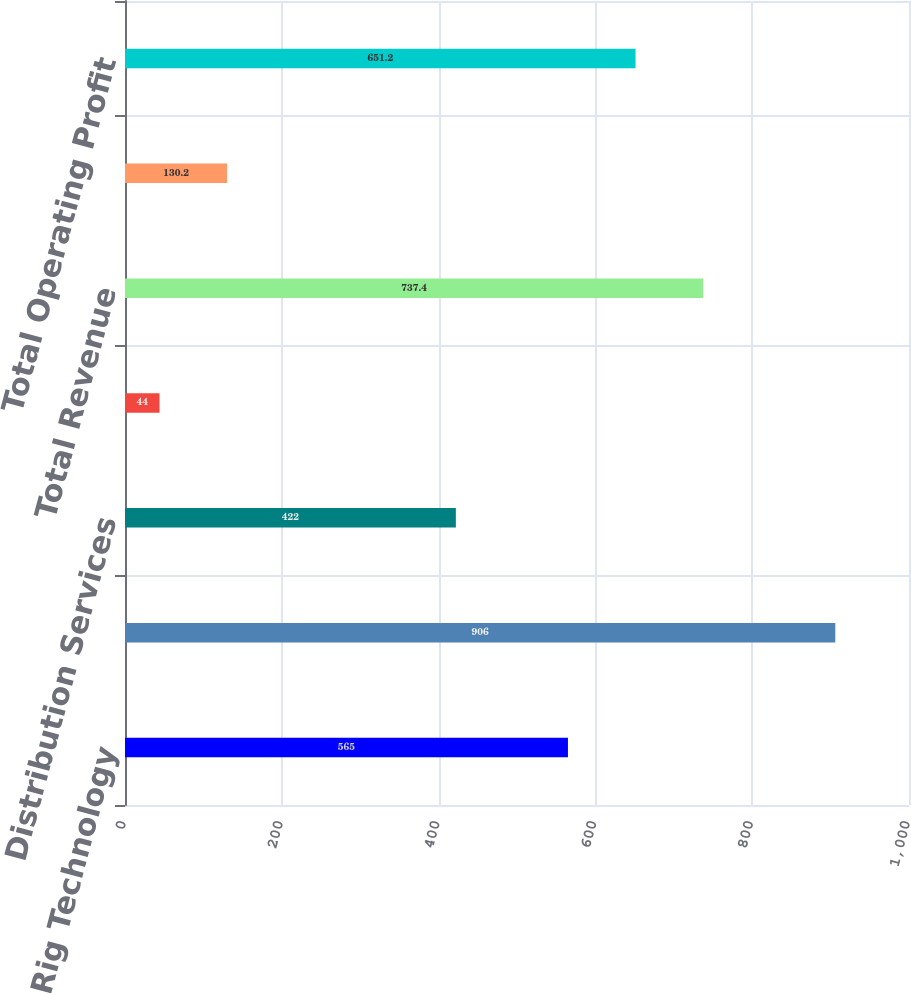Convert chart. <chart><loc_0><loc_0><loc_500><loc_500><bar_chart><fcel>Rig Technology<fcel>Petroleum Services & Supplies<fcel>Distribution Services<fcel>Eliminations<fcel>Total Revenue<fcel>Unallocated expenses and<fcel>Total Operating Profit<nl><fcel>565<fcel>906<fcel>422<fcel>44<fcel>737.4<fcel>130.2<fcel>651.2<nl></chart> 